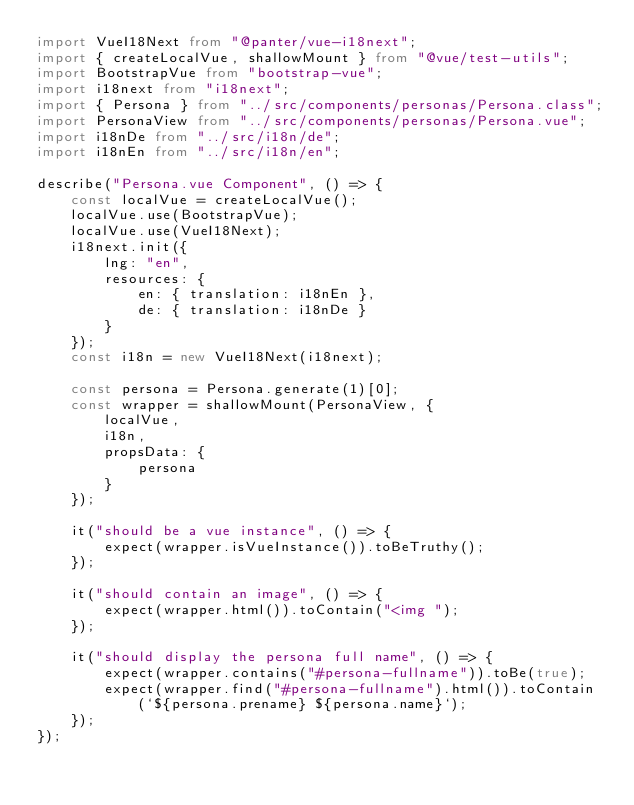<code> <loc_0><loc_0><loc_500><loc_500><_TypeScript_>import VueI18Next from "@panter/vue-i18next";
import { createLocalVue, shallowMount } from "@vue/test-utils";
import BootstrapVue from "bootstrap-vue";
import i18next from "i18next";
import { Persona } from "../src/components/personas/Persona.class";
import PersonaView from "../src/components/personas/Persona.vue";
import i18nDe from "../src/i18n/de";
import i18nEn from "../src/i18n/en";

describe("Persona.vue Component", () => {
    const localVue = createLocalVue();
    localVue.use(BootstrapVue);
    localVue.use(VueI18Next);
    i18next.init({
        lng: "en",
        resources: {
            en: { translation: i18nEn },
            de: { translation: i18nDe }
        }
    });
    const i18n = new VueI18Next(i18next);

    const persona = Persona.generate(1)[0];
    const wrapper = shallowMount(PersonaView, {
        localVue,
        i18n,
        propsData: {
            persona
        }
    });

    it("should be a vue instance", () => {
        expect(wrapper.isVueInstance()).toBeTruthy();
    });

    it("should contain an image", () => {
        expect(wrapper.html()).toContain("<img ");
    });

    it("should display the persona full name", () => {
        expect(wrapper.contains("#persona-fullname")).toBe(true);
        expect(wrapper.find("#persona-fullname").html()).toContain(`${persona.prename} ${persona.name}`);
    });
});
</code> 